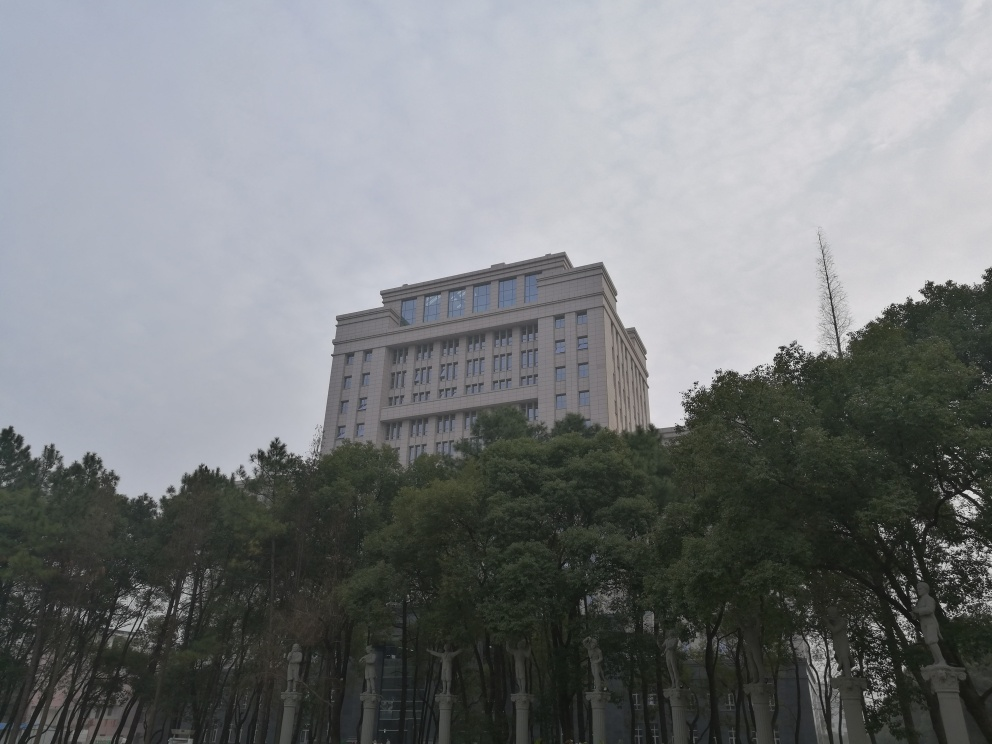What time of day does the lighting in this image suggest? The soft, diffuse lighting and the absence of long shadows suggest that the photo was likely taken on a cloudy day or during the early morning or late afternoon hours when the sun is not at its peak. The sky is overcast, and the ambient light casts a uniform illumination on the scene. 